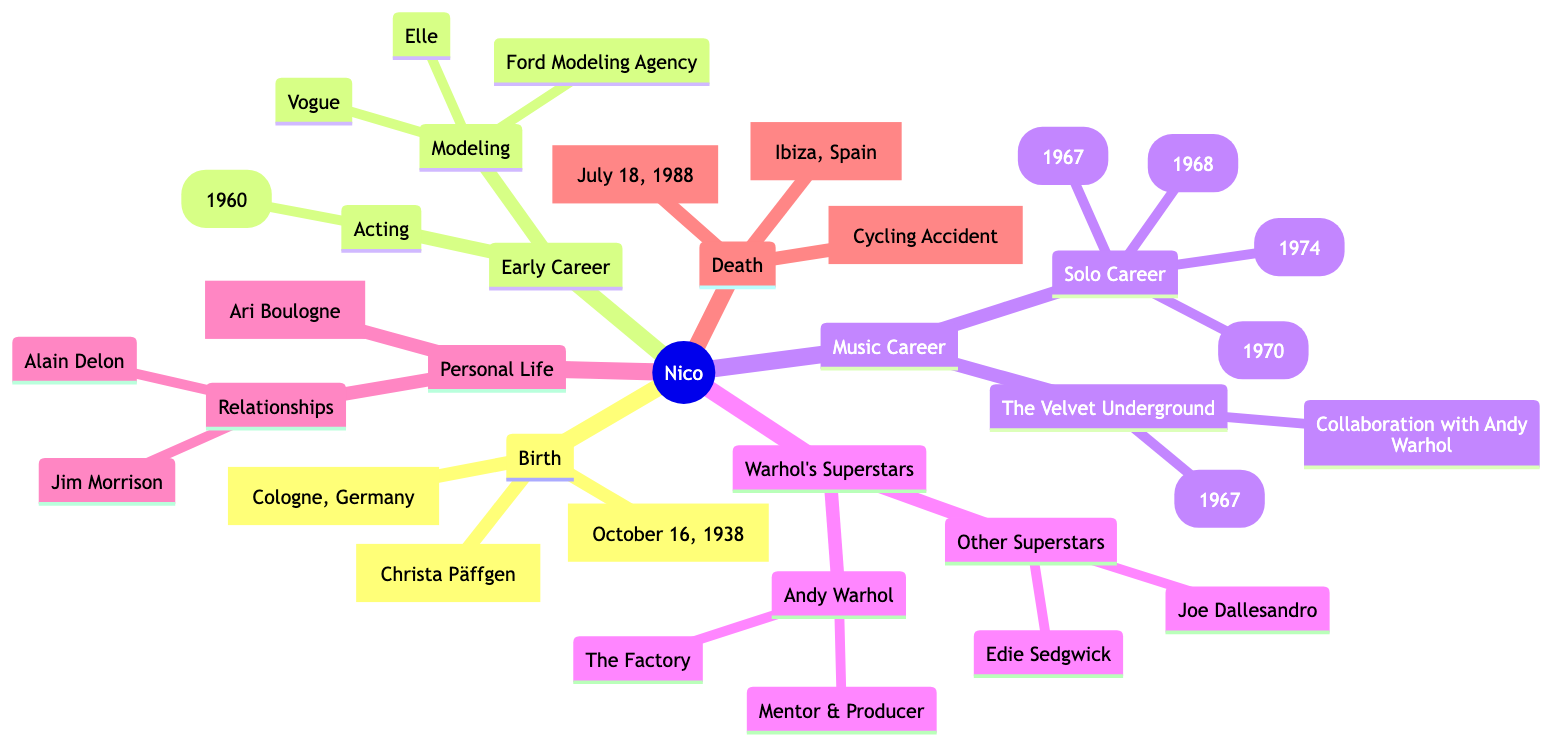What is Nico's birth name? The diagram states that Nico's birth name is found directly under the "Birth" section, specifically labeled as "Name".
Answer: Christa Päffgen When did Nico perform in the Fellini film? The diagram indicates that Nico acted in "La Dolce Vita" in 1960, which is noted under the "Acting" subsection of her "Early Career".
Answer: 1960 Which notable fashion magazines featured Nico as a model? The "Modeling" subsection under "Early Career" lists "Vogue" and "Elle" as the notable publications in which Nico was featured, while also indicating her agency.
Answer: Vogue, Elle What was the title of the album produced in collaboration with Andy Warhol? The diagram mentions that the album titled "The Velvet Underground & Nico" was released in 1967, which is under the "The Velvet Underground" section in the "Music Career".
Answer: The Velvet Underground & Nico (1967) How many notable solo albums did Nico produce? Under the "Solo Career" section in "Music Career", four albums are listed: "Chelsea Girl", "The Marble Index", "Desertshore", and "The End", indicating the total number.
Answer: 4 What relationship did Nico have with Jim Morrison? The diagram categorizes Jim Morrison under the "Relationships" subsection of "Personal Life", making it straightforward to conclude their association.
Answer: Relationship What caused Nico's death? The "Death" section states that Nico died from a cycling accident which is specified under the cause of her death.
Answer: Cycling Accident What year was Nico born? Nico's birth date, which is explicitly mentioned in the "Birth" section of the diagram, is directly relevant to the question regarding her year of birth.
Answer: 1938 Where did Nico pass away? The diagram explicitly states that Nico died in Ibiza, Spain, as noted in the "Death" section which informs where her death took place.
Answer: Ibiza, Spain 